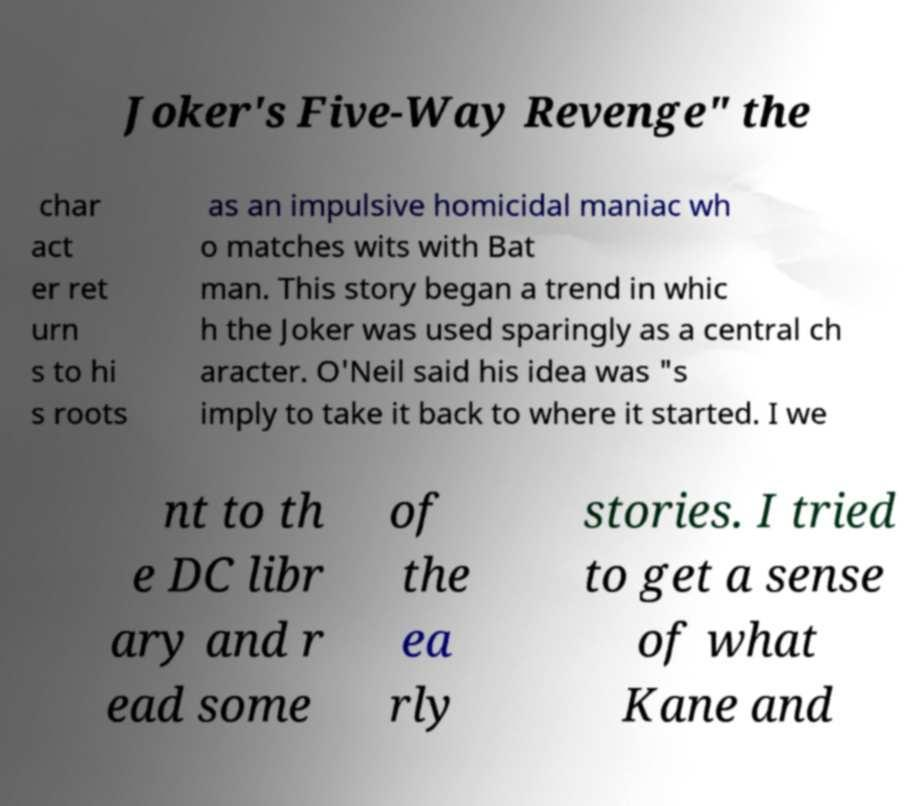Can you read and provide the text displayed in the image?This photo seems to have some interesting text. Can you extract and type it out for me? Joker's Five-Way Revenge" the char act er ret urn s to hi s roots as an impulsive homicidal maniac wh o matches wits with Bat man. This story began a trend in whic h the Joker was used sparingly as a central ch aracter. O'Neil said his idea was "s imply to take it back to where it started. I we nt to th e DC libr ary and r ead some of the ea rly stories. I tried to get a sense of what Kane and 